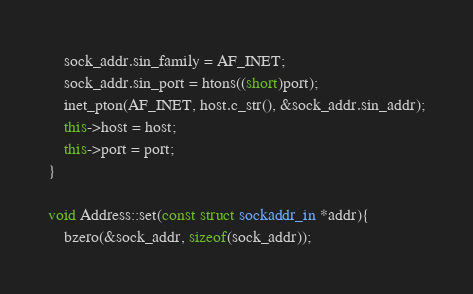<code> <loc_0><loc_0><loc_500><loc_500><_C++_>	sock_addr.sin_family = AF_INET;
	sock_addr.sin_port = htons((short)port);
	inet_pton(AF_INET, host.c_str(), &sock_addr.sin_addr);
	this->host = host;
	this->port = port;
}

void Address::set(const struct sockaddr_in *addr){
	bzero(&sock_addr, sizeof(sock_addr));</code> 